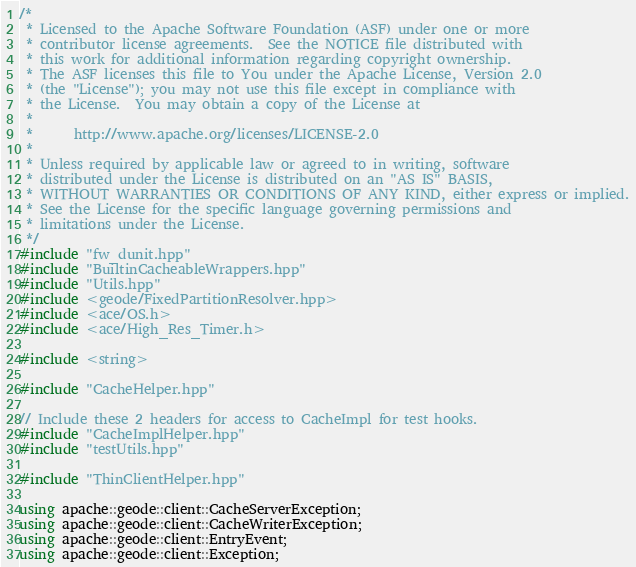Convert code to text. <code><loc_0><loc_0><loc_500><loc_500><_C++_>/*
 * Licensed to the Apache Software Foundation (ASF) under one or more
 * contributor license agreements.  See the NOTICE file distributed with
 * this work for additional information regarding copyright ownership.
 * The ASF licenses this file to You under the Apache License, Version 2.0
 * (the "License"); you may not use this file except in compliance with
 * the License.  You may obtain a copy of the License at
 *
 *      http://www.apache.org/licenses/LICENSE-2.0
 *
 * Unless required by applicable law or agreed to in writing, software
 * distributed under the License is distributed on an "AS IS" BASIS,
 * WITHOUT WARRANTIES OR CONDITIONS OF ANY KIND, either express or implied.
 * See the License for the specific language governing permissions and
 * limitations under the License.
 */
#include "fw_dunit.hpp"
#include "BuiltinCacheableWrappers.hpp"
#include "Utils.hpp"
#include <geode/FixedPartitionResolver.hpp>
#include <ace/OS.h>
#include <ace/High_Res_Timer.h>

#include <string>

#include "CacheHelper.hpp"

// Include these 2 headers for access to CacheImpl for test hooks.
#include "CacheImplHelper.hpp"
#include "testUtils.hpp"

#include "ThinClientHelper.hpp"

using apache::geode::client::CacheServerException;
using apache::geode::client::CacheWriterException;
using apache::geode::client::EntryEvent;
using apache::geode::client::Exception;</code> 